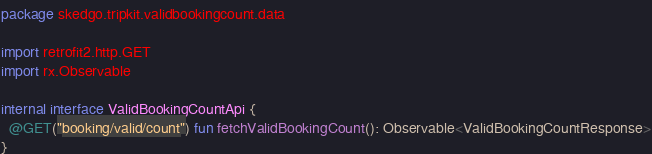<code> <loc_0><loc_0><loc_500><loc_500><_Kotlin_>package skedgo.tripkit.validbookingcount.data

import retrofit2.http.GET
import rx.Observable

internal interface ValidBookingCountApi {
  @GET("booking/valid/count") fun fetchValidBookingCount(): Observable<ValidBookingCountResponse>
}
</code> 